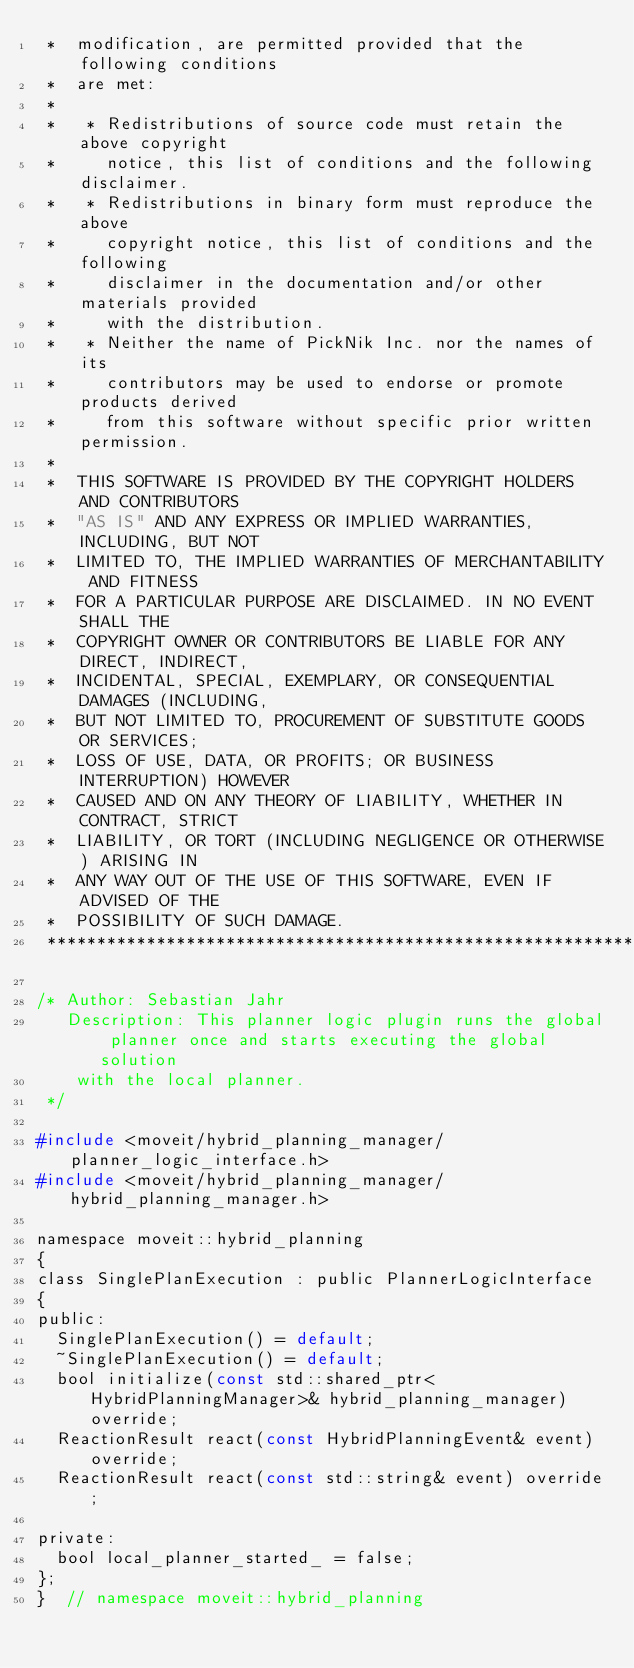<code> <loc_0><loc_0><loc_500><loc_500><_C_> *  modification, are permitted provided that the following conditions
 *  are met:
 *
 *   * Redistributions of source code must retain the above copyright
 *     notice, this list of conditions and the following disclaimer.
 *   * Redistributions in binary form must reproduce the above
 *     copyright notice, this list of conditions and the following
 *     disclaimer in the documentation and/or other materials provided
 *     with the distribution.
 *   * Neither the name of PickNik Inc. nor the names of its
 *     contributors may be used to endorse or promote products derived
 *     from this software without specific prior written permission.
 *
 *  THIS SOFTWARE IS PROVIDED BY THE COPYRIGHT HOLDERS AND CONTRIBUTORS
 *  "AS IS" AND ANY EXPRESS OR IMPLIED WARRANTIES, INCLUDING, BUT NOT
 *  LIMITED TO, THE IMPLIED WARRANTIES OF MERCHANTABILITY AND FITNESS
 *  FOR A PARTICULAR PURPOSE ARE DISCLAIMED. IN NO EVENT SHALL THE
 *  COPYRIGHT OWNER OR CONTRIBUTORS BE LIABLE FOR ANY DIRECT, INDIRECT,
 *  INCIDENTAL, SPECIAL, EXEMPLARY, OR CONSEQUENTIAL DAMAGES (INCLUDING,
 *  BUT NOT LIMITED TO, PROCUREMENT OF SUBSTITUTE GOODS OR SERVICES;
 *  LOSS OF USE, DATA, OR PROFITS; OR BUSINESS INTERRUPTION) HOWEVER
 *  CAUSED AND ON ANY THEORY OF LIABILITY, WHETHER IN CONTRACT, STRICT
 *  LIABILITY, OR TORT (INCLUDING NEGLIGENCE OR OTHERWISE) ARISING IN
 *  ANY WAY OUT OF THE USE OF THIS SOFTWARE, EVEN IF ADVISED OF THE
 *  POSSIBILITY OF SUCH DAMAGE.
 *********************************************************************/

/* Author: Sebastian Jahr
   Description: This planner logic plugin runs the global planner once and starts executing the global solution
    with the local planner.
 */

#include <moveit/hybrid_planning_manager/planner_logic_interface.h>
#include <moveit/hybrid_planning_manager/hybrid_planning_manager.h>

namespace moveit::hybrid_planning
{
class SinglePlanExecution : public PlannerLogicInterface
{
public:
  SinglePlanExecution() = default;
  ~SinglePlanExecution() = default;
  bool initialize(const std::shared_ptr<HybridPlanningManager>& hybrid_planning_manager) override;
  ReactionResult react(const HybridPlanningEvent& event) override;
  ReactionResult react(const std::string& event) override;

private:
  bool local_planner_started_ = false;
};
}  // namespace moveit::hybrid_planning
</code> 